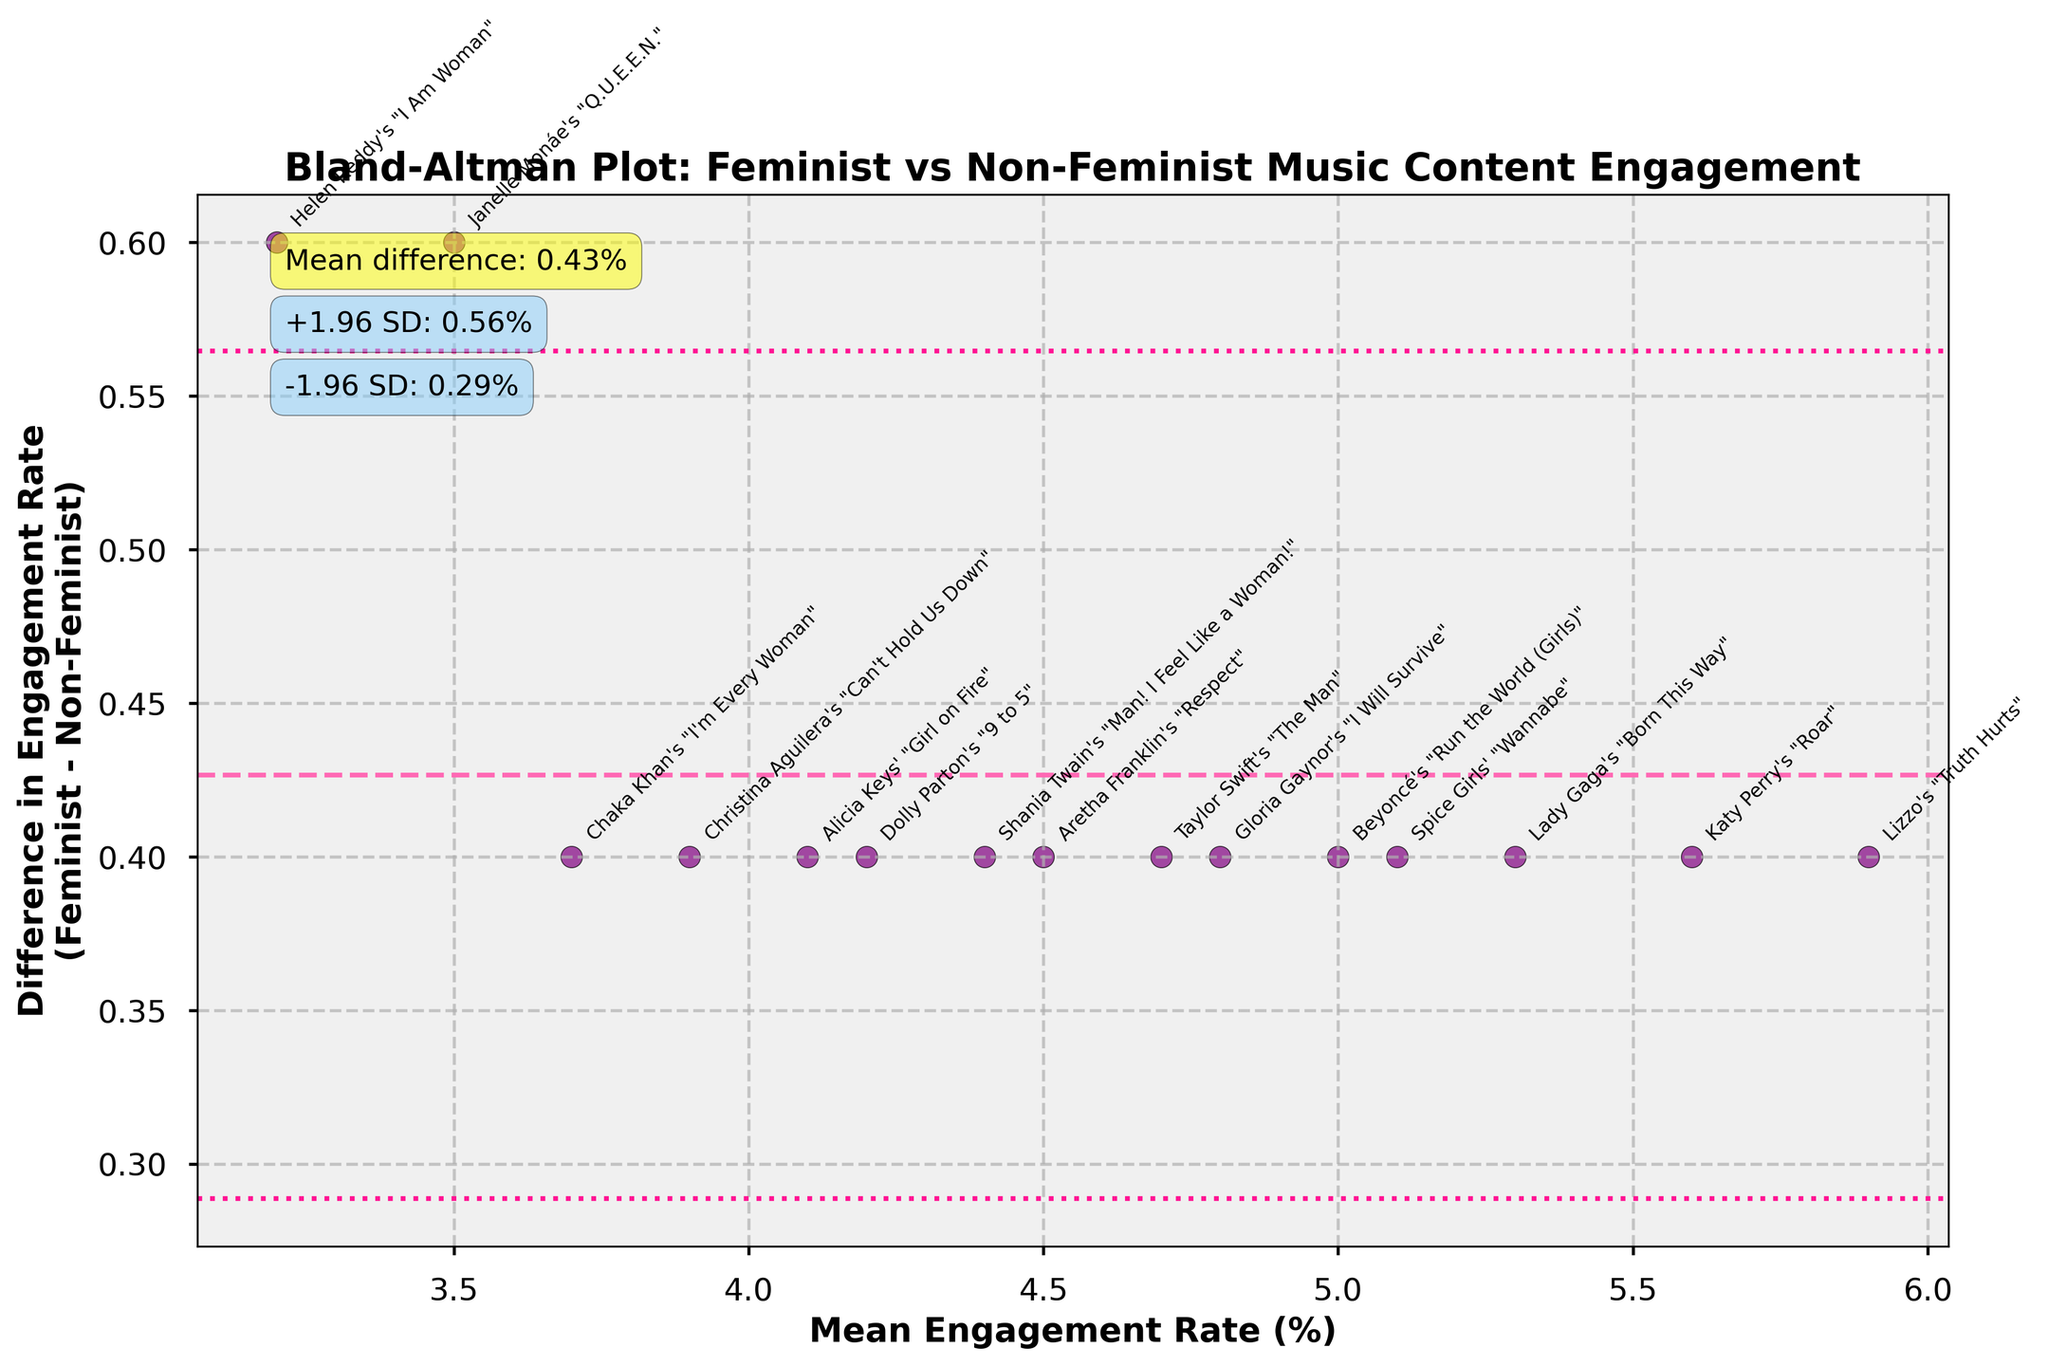What is the title of the chart? The title of the chart is displayed at the top and it reads "Bland-Altman Plot: Feminist vs Non-Feminist Music Content Engagement".
Answer: Bland-Altman Plot: Feminist vs Non-Feminist Music Content Engagement How many data points are plotted on the graph? Each data point corresponds to a song, and we can count 15 data points by the number of unique annotations on the figure.
Answer: 15 What do the dashed and dotted lines represent on the plot? The dashed line represents the mean difference in engagement rates, and the dotted lines represent the limits of agreement, which are ±1.96 standard deviations from the mean difference.
Answer: Mean difference and limits of agreement Where is the majority of the differences in engagement rates clustered on the y-axis? Most of the differences in engagement rates are clustered around the mean difference and within ±1.96 standard deviations from it, meaning they are closely packed between the dotted lines.
Answer: Around the mean difference and within ±1.96 SD Which data point shows the largest positive difference in engagement rates? "Helen Reddy's 'I Am Woman'" has the largest positive difference in engagement rates, as seen by its highest position above the mean difference line on the y-axis.
Answer: Helen Reddy's "I Am Woman" How is the mean engagement rate calculated for each point? The mean engagement rate for each point is calculated as the average of the feminist and non-feminist engagement rates for that song.
Answer: Average of the feminist and non-feminist engagement rates What is the mean difference in engagement rates between feminist and non-feminist content? The mean difference is indicated on the chart as the value of the dashed line, annotated as "Mean difference: 0.42%".
Answer: 0.42% Which songs have differences in engagement rates close to the mean difference? "Beyoncé's 'Run the World (Girls)'" and "Gloria Gaynor's 'I Will Survive'" both have differences that appear close to the mean difference line.
Answer: Beyoncé's "Run the World (Girls)" and Gloria Gaynor's "I Will Survive" What is the upper limit of agreement for the differences in engagement rates? The upper limit of agreement is calculated as the mean difference plus 1.96 times the standard deviation, annotated as "+1.96 SD: 0.98%".
Answer: 0.98% What is the lower limit of agreement for the differences in engagement rates? The lower limit of agreement is calculated as the mean difference minus 1.96 times the standard deviation, annotated as "-1.96 SD: -0.14%".
Answer: -0.14% 